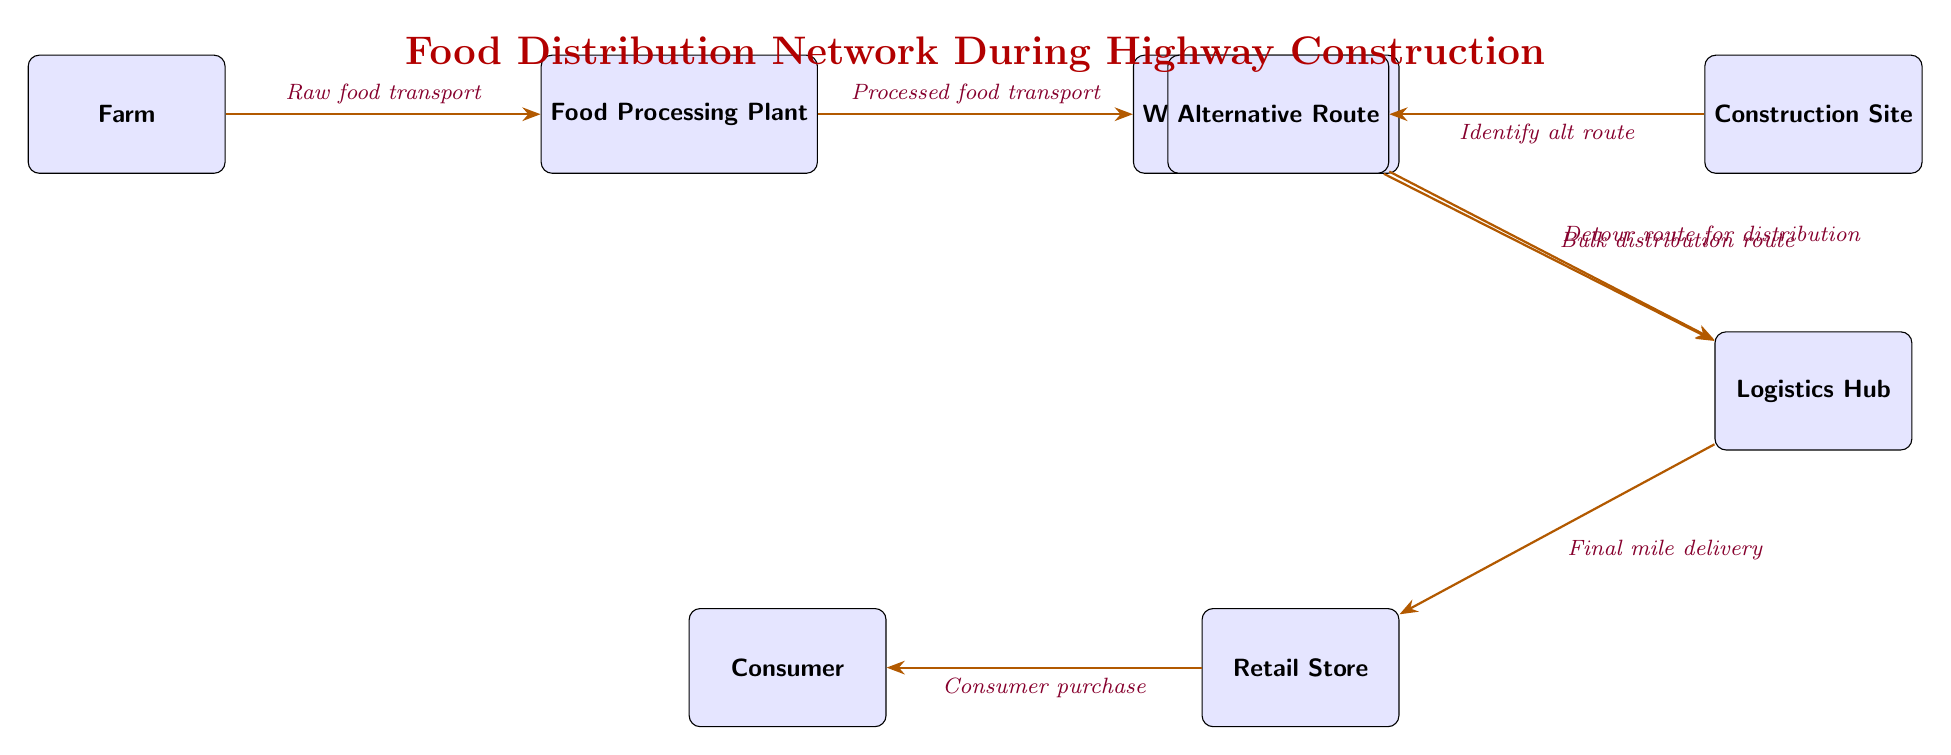What is the first node in the food distribution network? The first node in the diagram is labeled "Farm," indicating where raw food is produced before entering the supply chain.
Answer: Farm How many nodes are present in the diagram? Counting each labeled box including the "Construction Site" and "Alternative Route," there are a total of 6 nodes in the food distribution network.
Answer: 6 Which node receives processed food from the Food Processing Plant? The node labeled "Wholesale Distributor" is the one that receives processed food from the Food Processing Plant.
Answer: Wholesale Distributor What transport method is used from the Logistics Hub to the Retail Store? The connection between the Logistics Hub and Retail Store indicates the transport method is classified as "Final mile delivery."
Answer: Final mile delivery What alternative does the Construction Site lead to? The arrows show that the Construction Site leads to an "Alternative Route," indicating a detour needed for distribution due to construction activities.
Answer: Alternative Route How does the distribution network respond to highway construction? The diagram shows that the network identifies an alternative route, which is utilized for distribution to maintain functionality during road construction.
Answer: Identify alt route What type of transport is indicated between the Wholesale Distributor and the Logistics Hub? The transport method indicated in the diagram between these two nodes is a "Bulk distribution route."
Answer: Bulk distribution route What is the final step before the consumer purchases food? The final step before a consumer can purchase food is represented by the "Retail Store," where consumers make their purchases after final mile delivery.
Answer: Retail Store What is the flow direction from the Food Processing Plant? The flow direction from the Food Processing Plant goes to the Wholesale Distributor, which receives processed food from this node.
Answer: Wholesale Distributor 